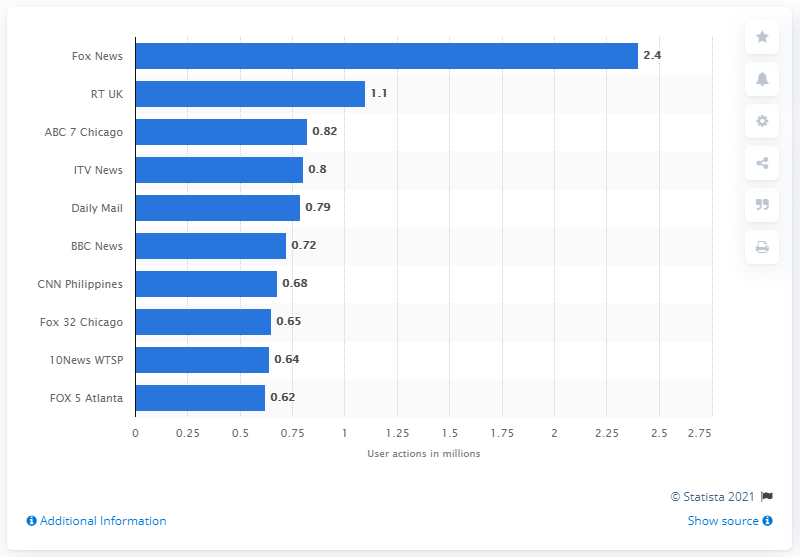Identify some key points in this picture. In June 2017, Fox News had 2,400 user engagements on their Facebook Live stream. RT UK's total user engagement was 1.1. 